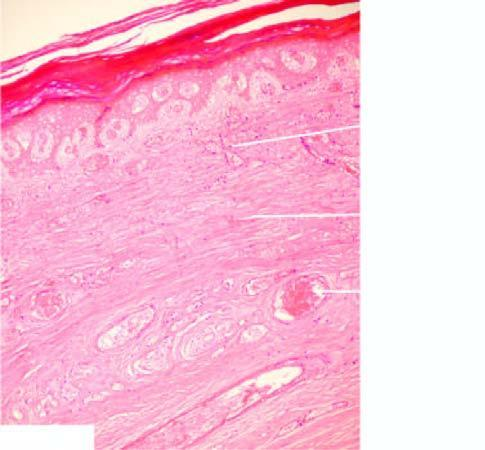what shows coagulativenecrosis of the skin, muscle and other soft tissue, and thrombsed vessels?
Answer the question using a single word or phrase. Microscopy 